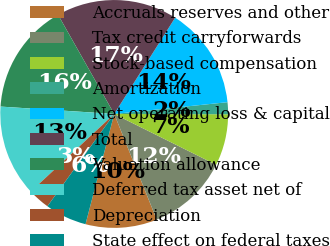Convert chart. <chart><loc_0><loc_0><loc_500><loc_500><pie_chart><fcel>Accruals reserves and other<fcel>Tax credit carryforwards<fcel>Stock-based compensation<fcel>Amortization<fcel>Net operating loss & capital<fcel>Total<fcel>Valuation allowance<fcel>Deferred tax asset net of<fcel>Depreciation<fcel>State effect on federal taxes<nl><fcel>10.14%<fcel>11.55%<fcel>7.32%<fcel>1.69%<fcel>14.37%<fcel>17.18%<fcel>15.77%<fcel>12.96%<fcel>3.1%<fcel>5.92%<nl></chart> 